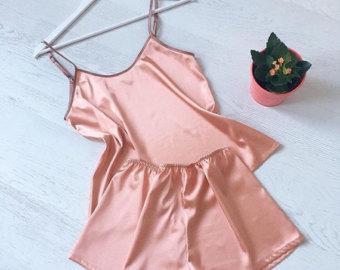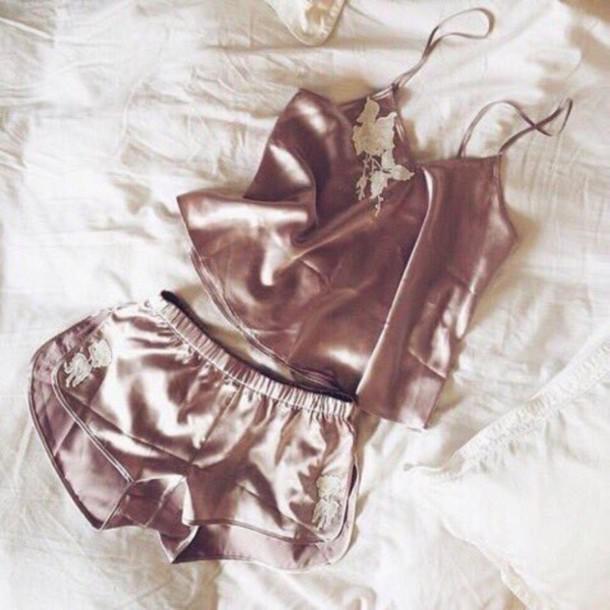The first image is the image on the left, the second image is the image on the right. Given the left and right images, does the statement "At least one pajama is one piece and has a card or paper near it was a brand name." hold true? Answer yes or no. No. 